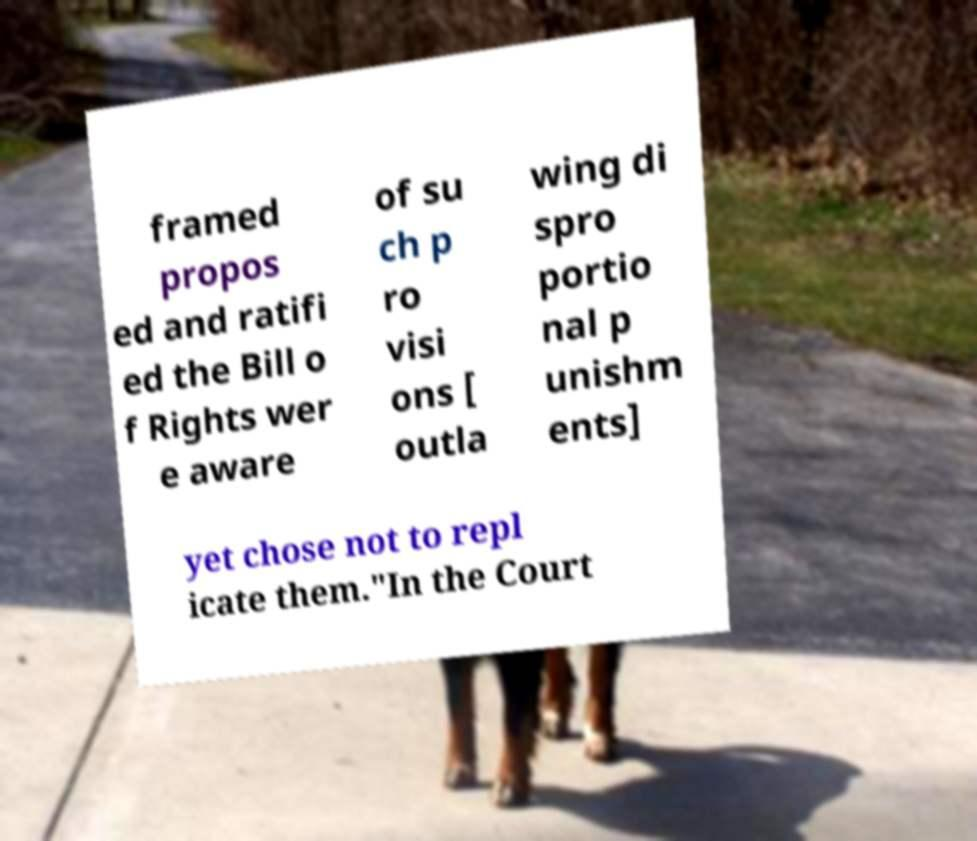Please read and relay the text visible in this image. What does it say? framed propos ed and ratifi ed the Bill o f Rights wer e aware of su ch p ro visi ons [ outla wing di spro portio nal p unishm ents] yet chose not to repl icate them."In the Court 